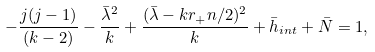<formula> <loc_0><loc_0><loc_500><loc_500>- \frac { j ( j - 1 ) } { ( k - 2 ) } - \frac { \bar { \lambda } ^ { 2 } } { k } + \frac { ( \bar { \lambda } - k r _ { + } n / 2 ) ^ { 2 } } { k } + \bar { h } _ { i n t } + \bar { N } = 1 ,</formula> 